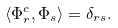Convert formula to latex. <formula><loc_0><loc_0><loc_500><loc_500>\langle \Phi _ { r } ^ { c } , \Phi _ { s } \rangle = \delta _ { r s } .</formula> 